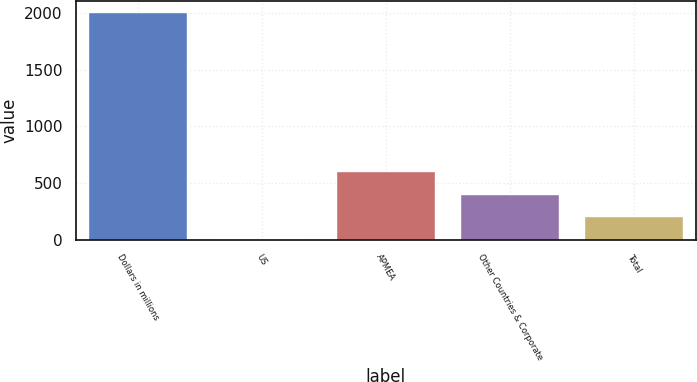Convert chart. <chart><loc_0><loc_0><loc_500><loc_500><bar_chart><fcel>Dollars in millions<fcel>US<fcel>APMEA<fcel>Other Countries & Corporate<fcel>Total<nl><fcel>2010<fcel>4<fcel>605.8<fcel>405.2<fcel>204.6<nl></chart> 